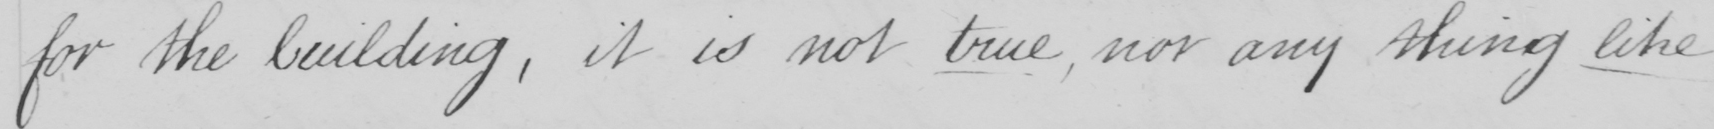Can you tell me what this handwritten text says? for the building  , it is not true , nor any thing like 